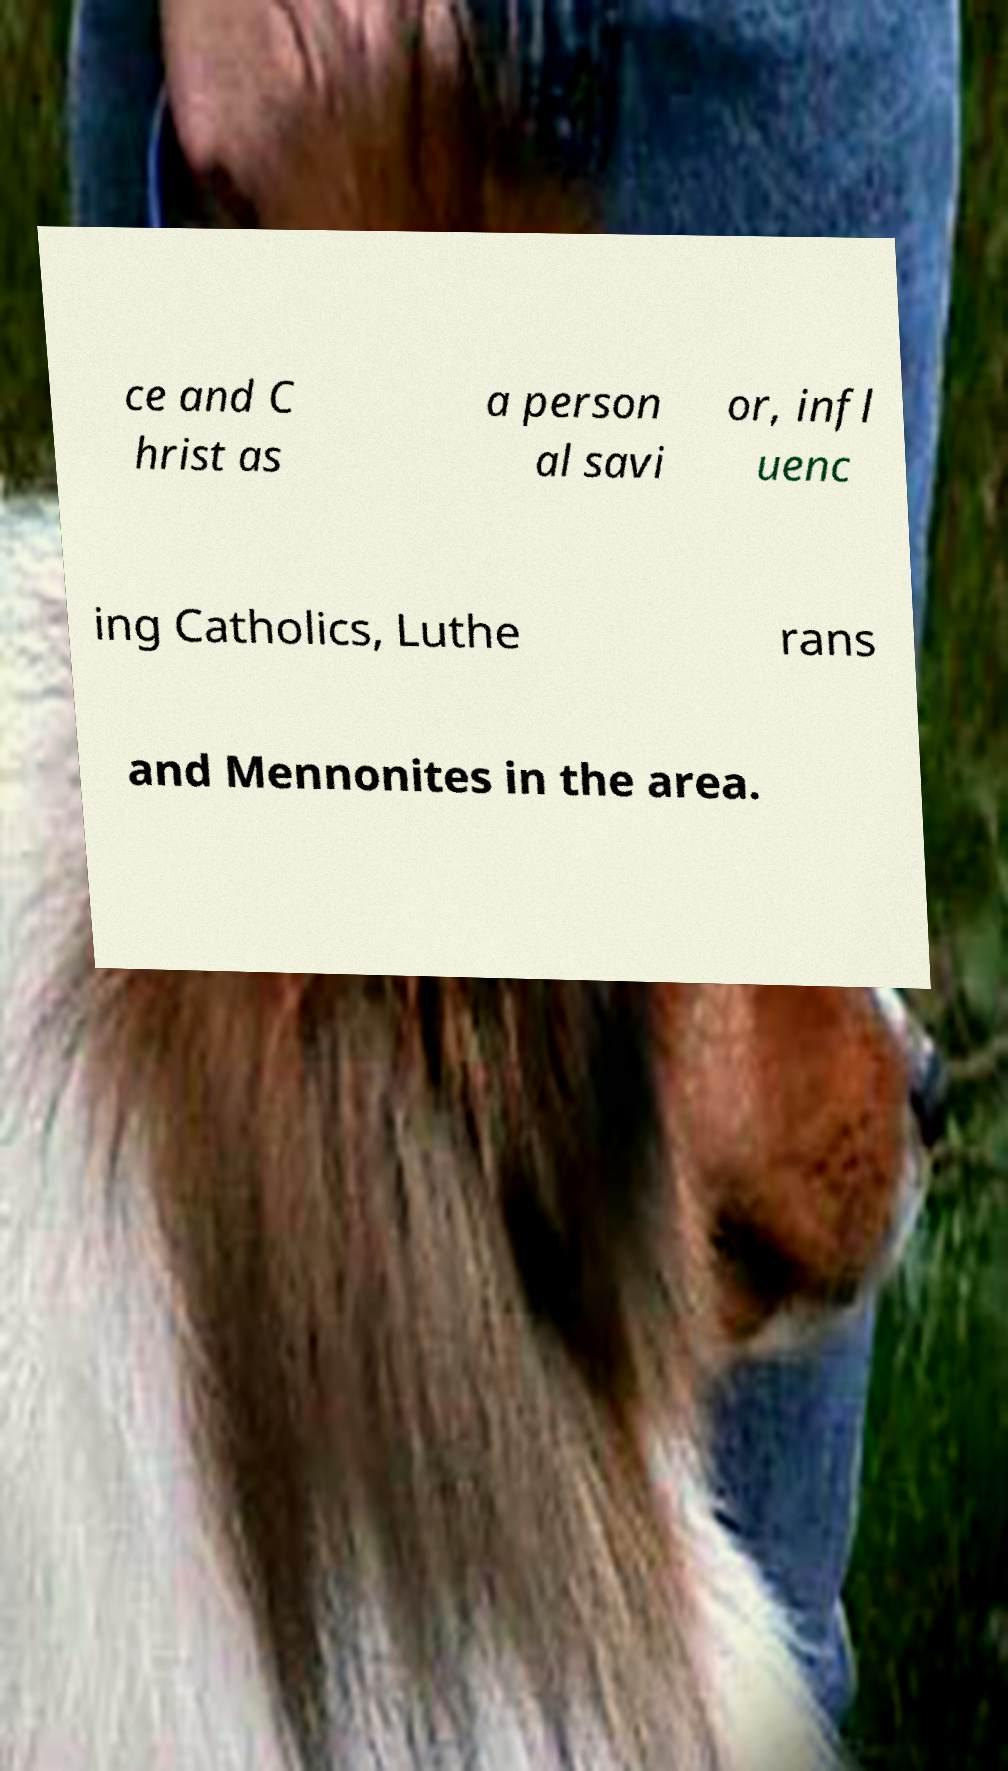Please read and relay the text visible in this image. What does it say? ce and C hrist as a person al savi or, infl uenc ing Catholics, Luthe rans and Mennonites in the area. 